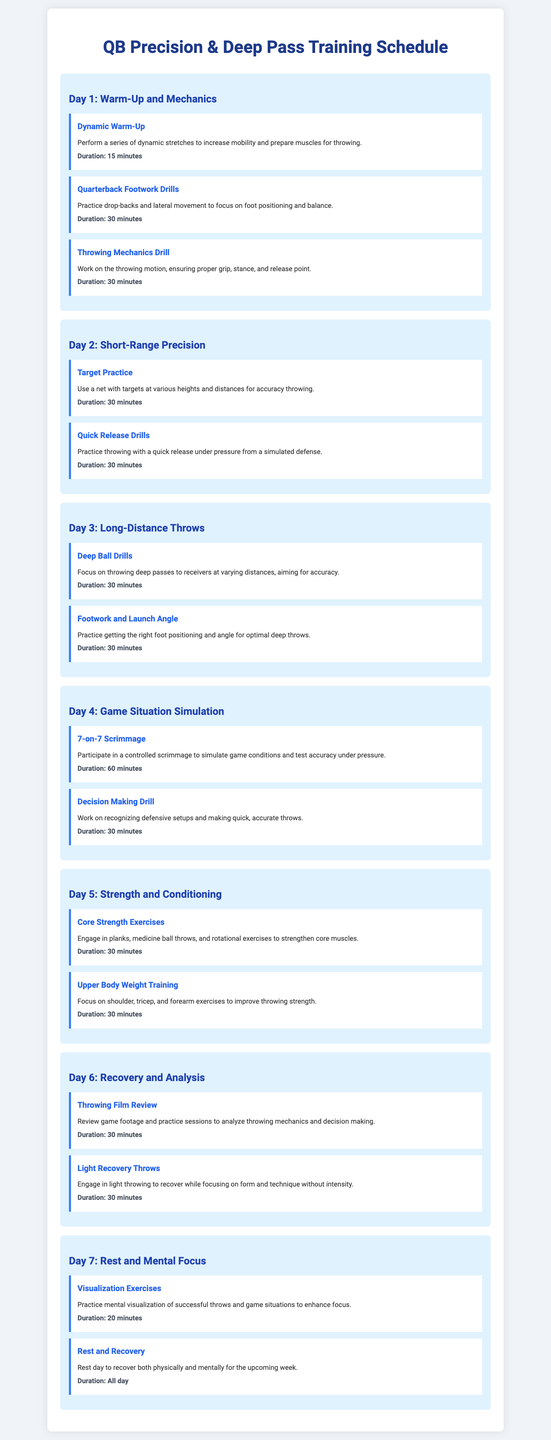What is the title of the document? The title of the document is stated at the top header of the rendered document, which is "QB Precision & Deep Pass Training Schedule."
Answer: QB Precision & Deep Pass Training Schedule How long is the Dynamic Warm-Up drill? The duration of the Dynamic Warm-Up drill is specified in the document under its description.
Answer: 15 minutes What type of scrimmage is included on Day 4? The scrimmage type is mentioned in Day 4 of the training schedule, highlighting its nature.
Answer: 7-on-7 How many minutes is dedicated to Decision Making Drill? The duration for the Decision Making Drill is specified in Day 4 of the document, indicating the time allocated.
Answer: 30 minutes Which day's focus is on Long-Distance Throws? The day that focuses on Long-Distance Throws is labeled in the document under a specific title.
Answer: Day 3 What drill focuses on core strength? The document specifies a drill on Day 5 that addresses core strength through particular exercises.
Answer: Core Strength Exercises What is the focus of the visualization exercises? The focus of the visualization exercises is described in the context of mental preparation within Day 7.
Answer: Successful throws and game situations How many drills are listed for Day 6? The number of drills listed for Day 6 can be counted directly from the document under that day's section.
Answer: 2 